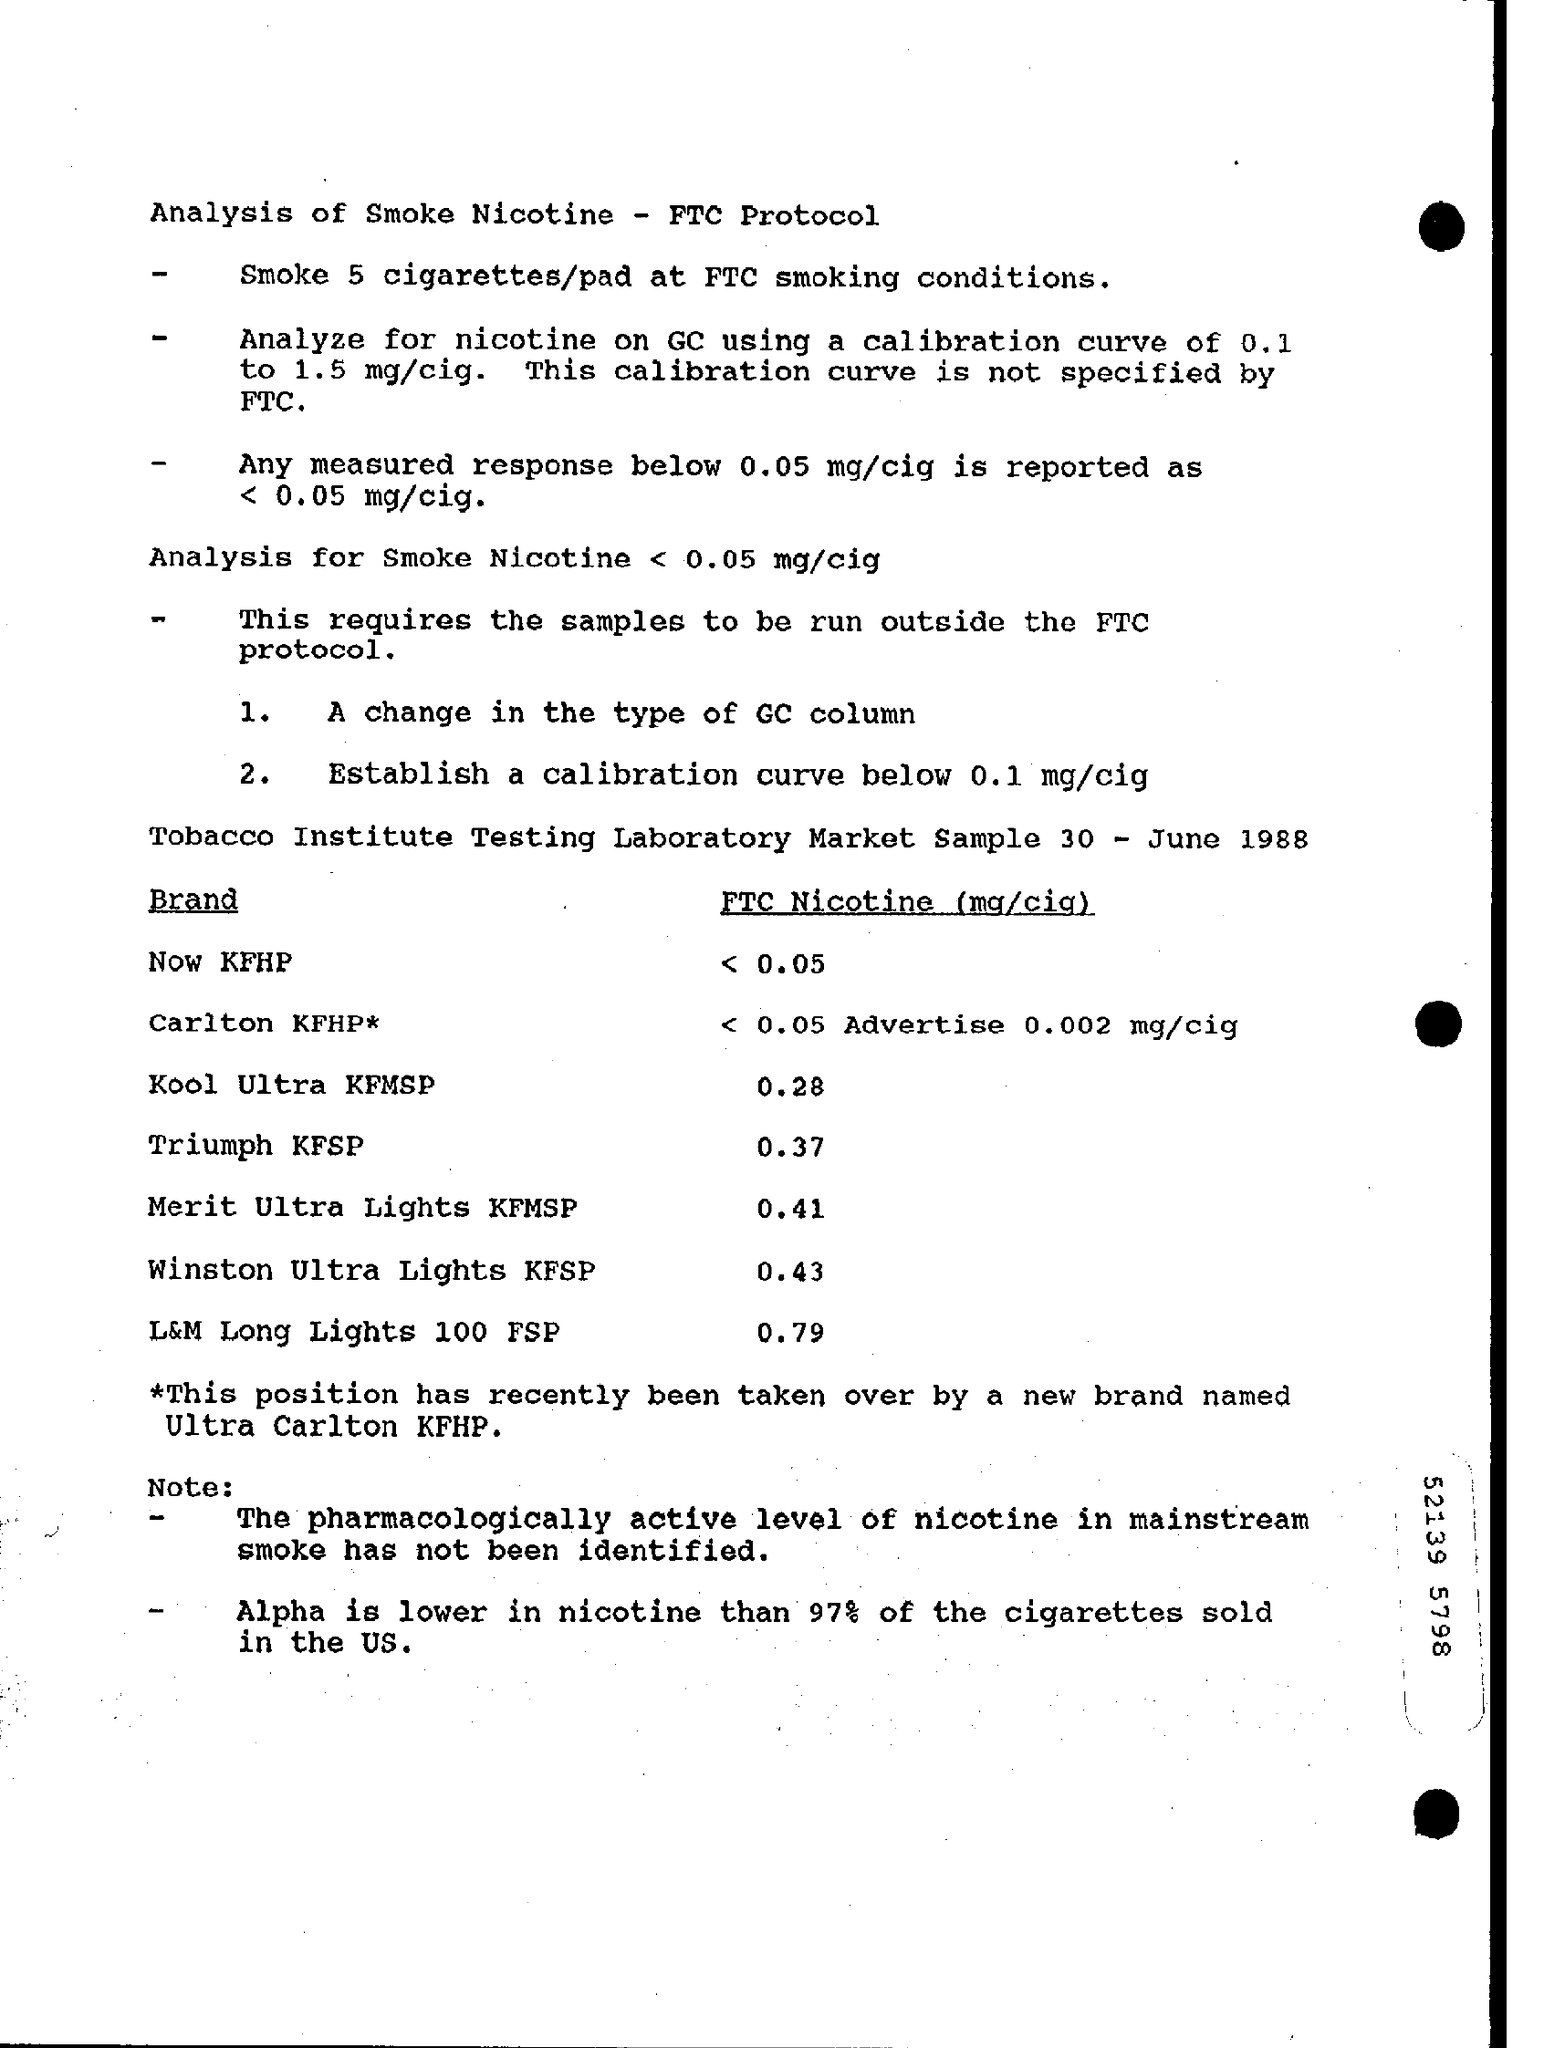How much cigerettes/pad can be smoked at FTC smoking condition?
Offer a very short reply. 5. What has been analyzed on GC using calibration curve of 0.1 to 1.5 mg/cig ?
Your answer should be compact. Nicotine. Based on which protocol,smoke nicotine is analysed?
Offer a very short reply. FTC protocol. What is the FTC Nicotin level for the brand 'Kool Ultra KFMSP' in mg/cig ?
Your answer should be very brief. 0.28. What is the FTC Nicotin level for the brand 'Triumph KFSP' in mg/cig ?
Give a very brief answer. 0.37. In which unit, FTC Nicotine level is measured?
Offer a terse response. Mg/cig. What is the FTC Nicotin level for the brand 'Winston Ultra Lights KFSP' in mg/cig ?
Your answer should be compact. 0.43. 